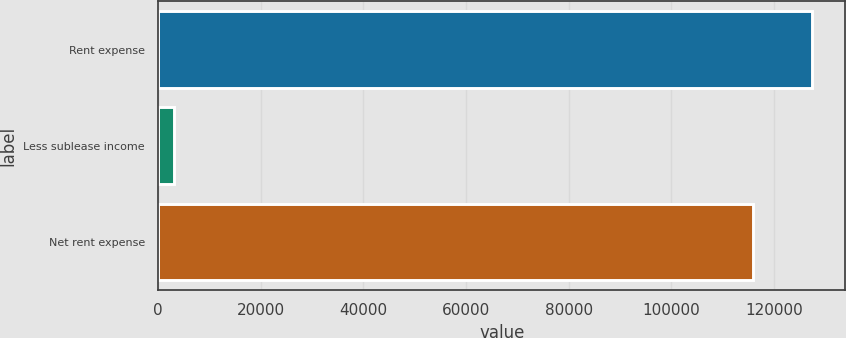Convert chart to OTSL. <chart><loc_0><loc_0><loc_500><loc_500><bar_chart><fcel>Rent expense<fcel>Less sublease income<fcel>Net rent expense<nl><fcel>127511<fcel>3057<fcel>115919<nl></chart> 